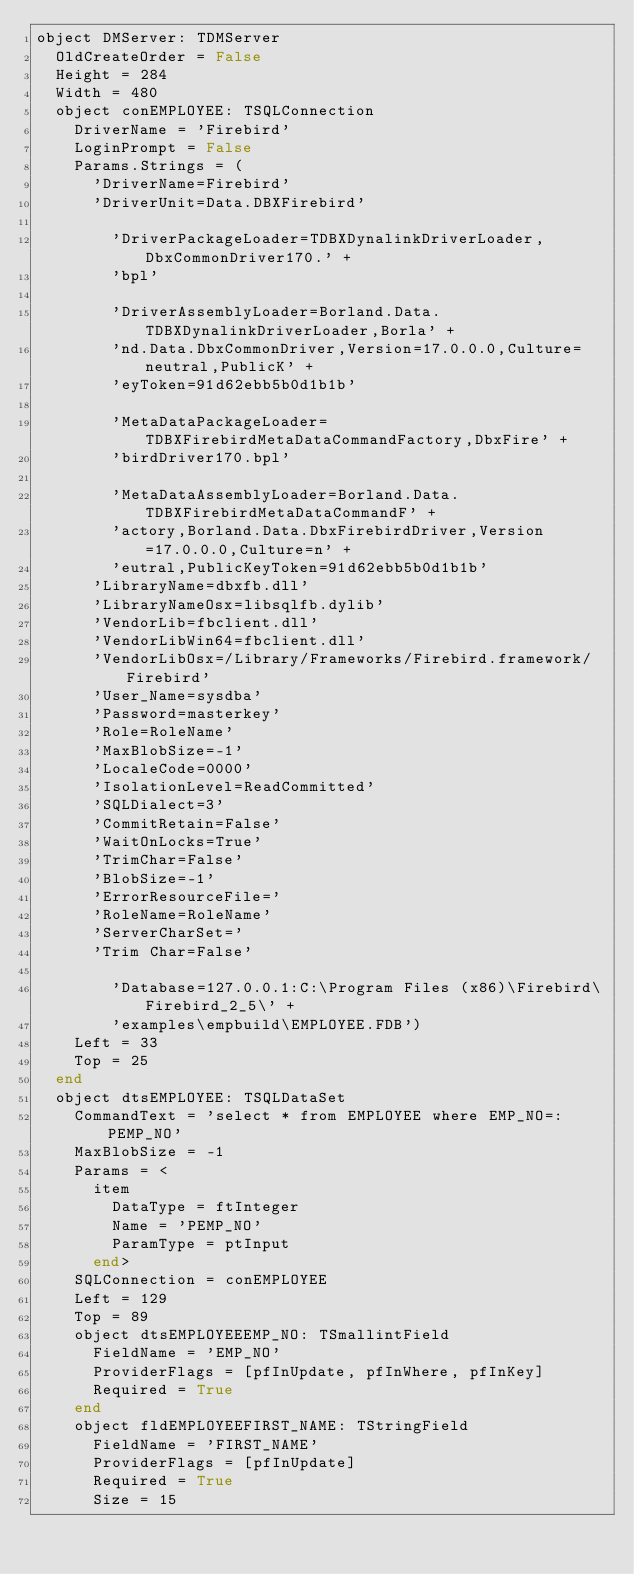Convert code to text. <code><loc_0><loc_0><loc_500><loc_500><_Pascal_>object DMServer: TDMServer
  OldCreateOrder = False
  Height = 284
  Width = 480
  object conEMPLOYEE: TSQLConnection
    DriverName = 'Firebird'
    LoginPrompt = False
    Params.Strings = (
      'DriverName=Firebird'
      'DriverUnit=Data.DBXFirebird'
      
        'DriverPackageLoader=TDBXDynalinkDriverLoader,DbxCommonDriver170.' +
        'bpl'
      
        'DriverAssemblyLoader=Borland.Data.TDBXDynalinkDriverLoader,Borla' +
        'nd.Data.DbxCommonDriver,Version=17.0.0.0,Culture=neutral,PublicK' +
        'eyToken=91d62ebb5b0d1b1b'
      
        'MetaDataPackageLoader=TDBXFirebirdMetaDataCommandFactory,DbxFire' +
        'birdDriver170.bpl'
      
        'MetaDataAssemblyLoader=Borland.Data.TDBXFirebirdMetaDataCommandF' +
        'actory,Borland.Data.DbxFirebirdDriver,Version=17.0.0.0,Culture=n' +
        'eutral,PublicKeyToken=91d62ebb5b0d1b1b'
      'LibraryName=dbxfb.dll'
      'LibraryNameOsx=libsqlfb.dylib'
      'VendorLib=fbclient.dll'
      'VendorLibWin64=fbclient.dll'
      'VendorLibOsx=/Library/Frameworks/Firebird.framework/Firebird'
      'User_Name=sysdba'
      'Password=masterkey'
      'Role=RoleName'
      'MaxBlobSize=-1'
      'LocaleCode=0000'
      'IsolationLevel=ReadCommitted'
      'SQLDialect=3'
      'CommitRetain=False'
      'WaitOnLocks=True'
      'TrimChar=False'
      'BlobSize=-1'
      'ErrorResourceFile='
      'RoleName=RoleName'
      'ServerCharSet='
      'Trim Char=False'
      
        'Database=127.0.0.1:C:\Program Files (x86)\Firebird\Firebird_2_5\' +
        'examples\empbuild\EMPLOYEE.FDB')
    Left = 33
    Top = 25
  end
  object dtsEMPLOYEE: TSQLDataSet
    CommandText = 'select * from EMPLOYEE where EMP_NO=:PEMP_NO'
    MaxBlobSize = -1
    Params = <
      item
        DataType = ftInteger
        Name = 'PEMP_NO'
        ParamType = ptInput
      end>
    SQLConnection = conEMPLOYEE
    Left = 129
    Top = 89
    object dtsEMPLOYEEEMP_NO: TSmallintField
      FieldName = 'EMP_NO'
      ProviderFlags = [pfInUpdate, pfInWhere, pfInKey]
      Required = True
    end
    object fldEMPLOYEEFIRST_NAME: TStringField
      FieldName = 'FIRST_NAME'
      ProviderFlags = [pfInUpdate]
      Required = True
      Size = 15</code> 